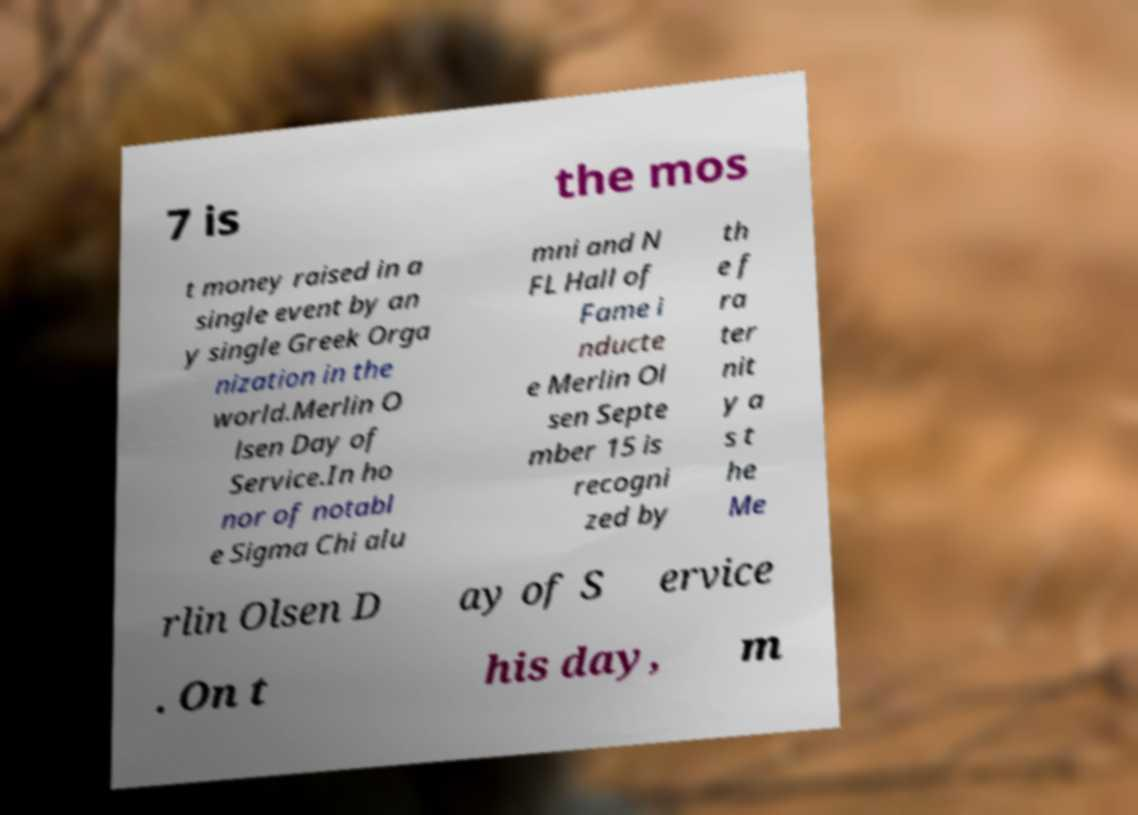For documentation purposes, I need the text within this image transcribed. Could you provide that? 7 is the mos t money raised in a single event by an y single Greek Orga nization in the world.Merlin O lsen Day of Service.In ho nor of notabl e Sigma Chi alu mni and N FL Hall of Fame i nducte e Merlin Ol sen Septe mber 15 is recogni zed by th e f ra ter nit y a s t he Me rlin Olsen D ay of S ervice . On t his day, m 